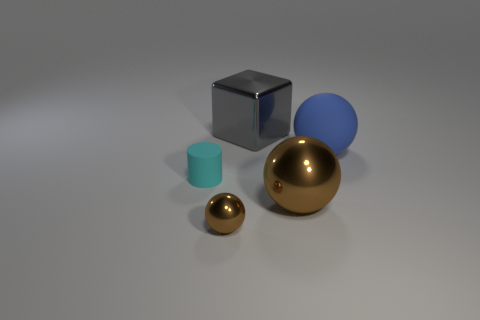Add 3 green objects. How many objects exist? 8 Subtract all spheres. How many objects are left? 2 Subtract 0 cyan cubes. How many objects are left? 5 Subtract all cyan things. Subtract all blue matte balls. How many objects are left? 3 Add 5 big metallic spheres. How many big metallic spheres are left? 6 Add 4 tiny shiny spheres. How many tiny shiny spheres exist? 5 